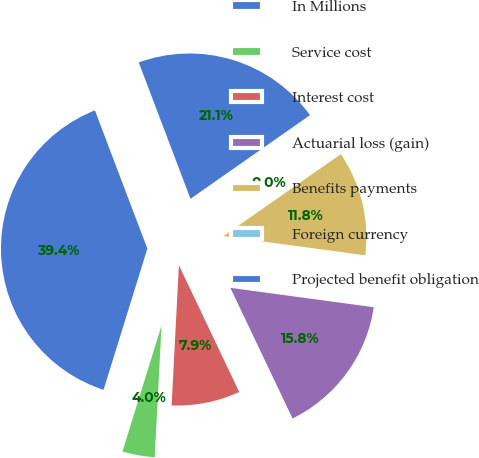<chart> <loc_0><loc_0><loc_500><loc_500><pie_chart><fcel>In Millions<fcel>Service cost<fcel>Interest cost<fcel>Actuarial loss (gain)<fcel>Benefits payments<fcel>Foreign currency<fcel>Projected benefit obligation<nl><fcel>39.44%<fcel>3.96%<fcel>7.9%<fcel>15.79%<fcel>11.84%<fcel>0.02%<fcel>21.05%<nl></chart> 